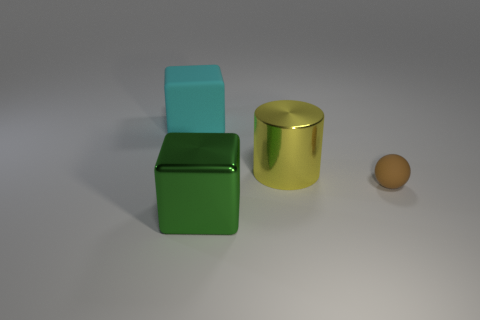Add 4 purple rubber cylinders. How many objects exist? 8 Subtract all cylinders. How many objects are left? 3 Add 3 cyan cubes. How many cyan cubes exist? 4 Subtract 0 brown cylinders. How many objects are left? 4 Subtract all tiny gray rubber cubes. Subtract all big green metal cubes. How many objects are left? 3 Add 1 yellow cylinders. How many yellow cylinders are left? 2 